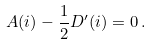Convert formula to latex. <formula><loc_0><loc_0><loc_500><loc_500>A ( i ) - \frac { 1 } { 2 } D ^ { \prime } ( i ) = 0 \, .</formula> 